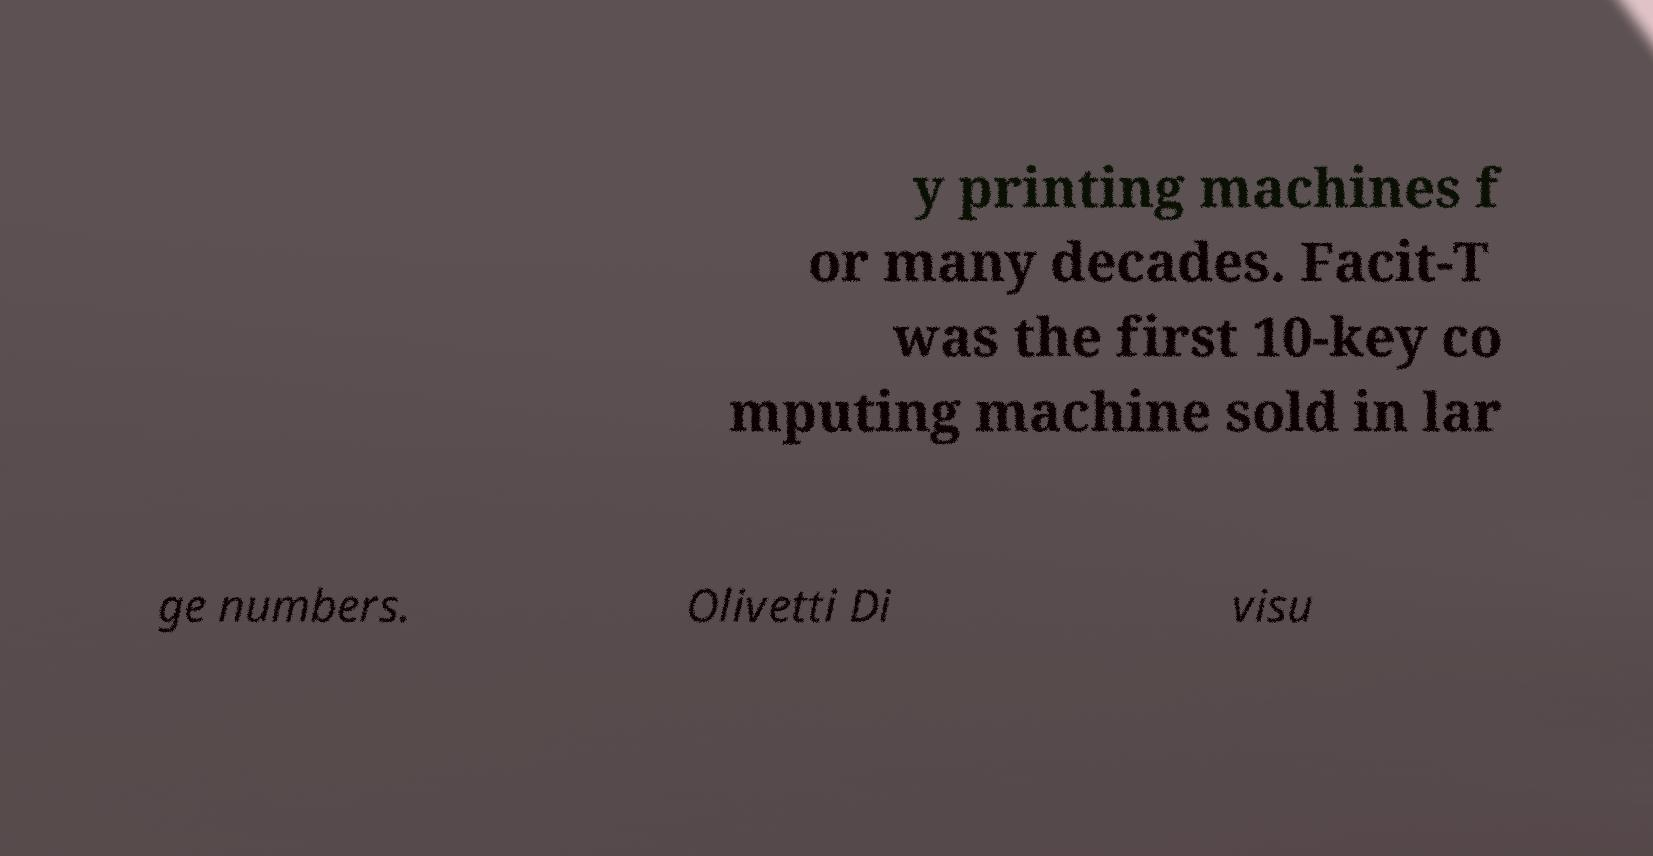There's text embedded in this image that I need extracted. Can you transcribe it verbatim? y printing machines f or many decades. Facit-T was the first 10-key co mputing machine sold in lar ge numbers. Olivetti Di visu 